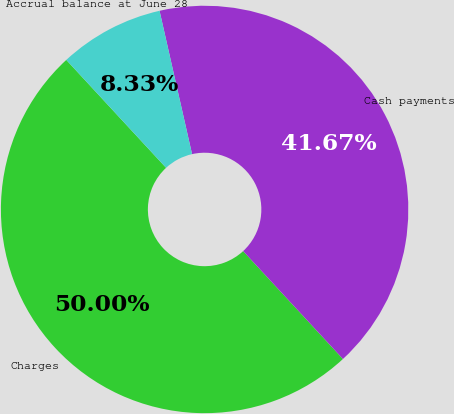Convert chart to OTSL. <chart><loc_0><loc_0><loc_500><loc_500><pie_chart><fcel>Charges<fcel>Cash payments<fcel>Accrual balance at June 28<nl><fcel>50.0%<fcel>41.67%<fcel>8.33%<nl></chart> 